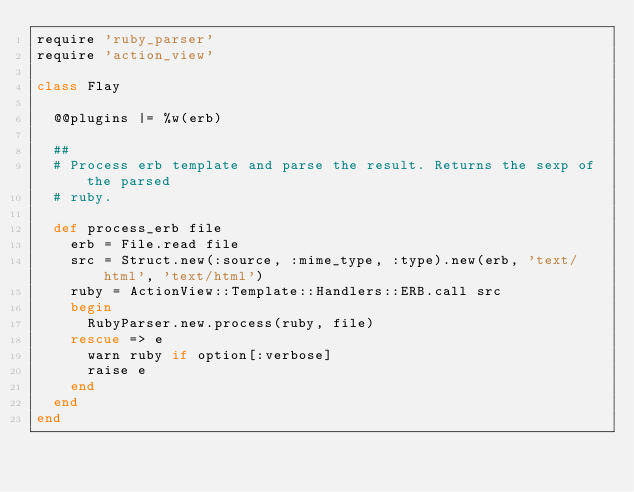<code> <loc_0><loc_0><loc_500><loc_500><_Ruby_>require 'ruby_parser'
require 'action_view'

class Flay
  
  @@plugins |= %w(erb)

  ##
  # Process erb template and parse the result. Returns the sexp of the parsed
  # ruby.
 
  def process_erb file
    erb = File.read file
    src = Struct.new(:source, :mime_type, :type).new(erb, 'text/html', 'text/html')
    ruby = ActionView::Template::Handlers::ERB.call src
    begin
      RubyParser.new.process(ruby, file)
    rescue => e
      warn ruby if option[:verbose]
      raise e
    end
  end
end
</code> 